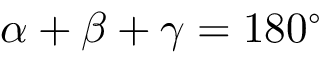Convert formula to latex. <formula><loc_0><loc_0><loc_500><loc_500>\alpha + \beta + \gamma = 1 8 0 ^ { \circ }</formula> 